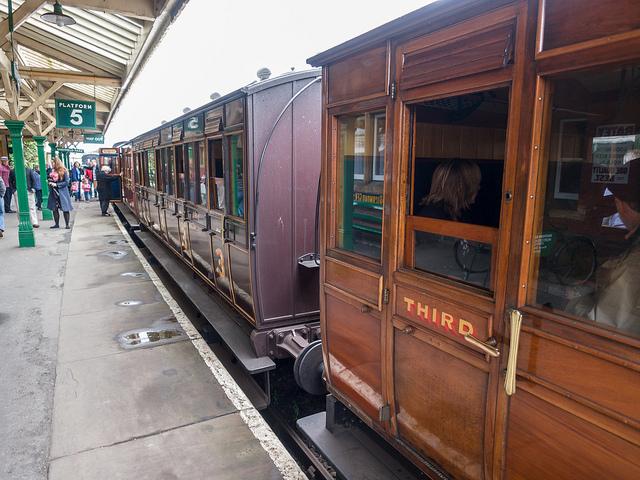Has it been a while since those handles were polished?
Short answer required. Yes. What is the number on the green sign?
Quick response, please. 5. Could you ride this train car today?
Short answer required. Yes. What color is the signpost?
Answer briefly. Green. Is the train wooden or metal?
Give a very brief answer. Wooden. What color is the train?
Keep it brief. Brown. 